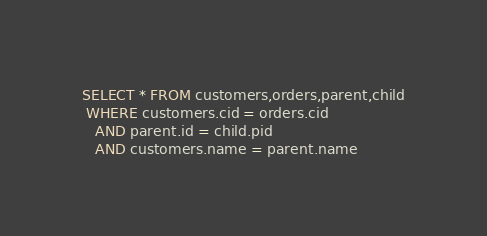<code> <loc_0><loc_0><loc_500><loc_500><_SQL_>SELECT * FROM customers,orders,parent,child
 WHERE customers.cid = orders.cid
   AND parent.id = child.pid
   AND customers.name = parent.name
</code> 